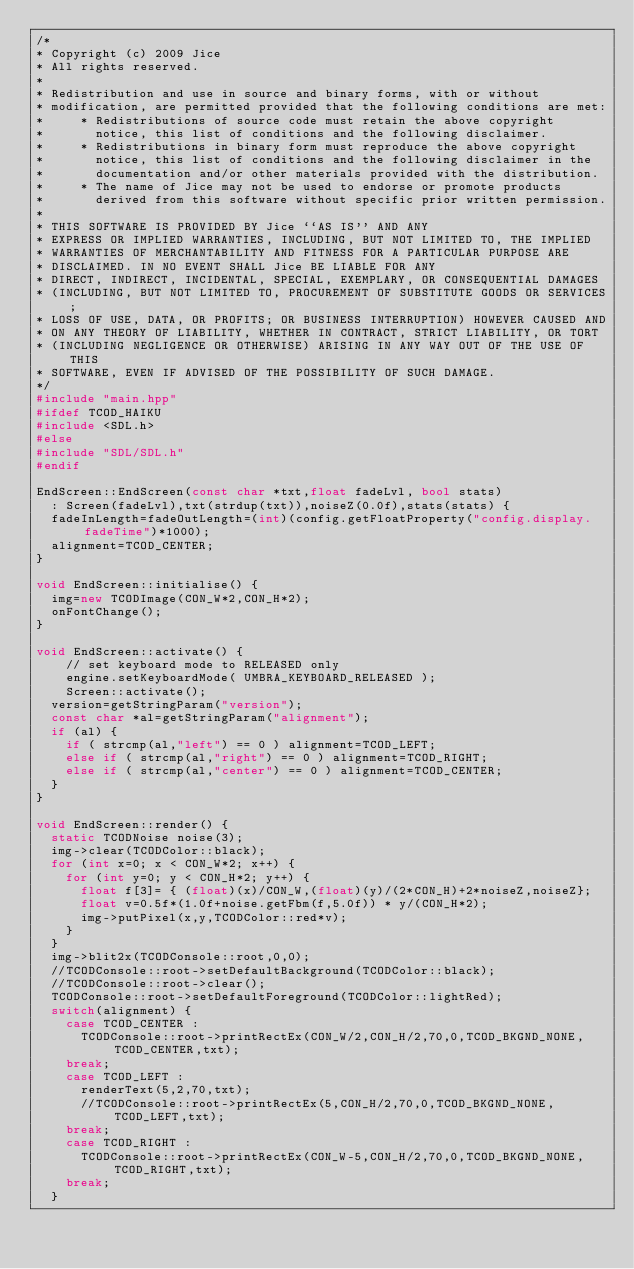Convert code to text. <code><loc_0><loc_0><loc_500><loc_500><_C++_>/*
* Copyright (c) 2009 Jice
* All rights reserved.
*
* Redistribution and use in source and binary forms, with or without
* modification, are permitted provided that the following conditions are met:
*     * Redistributions of source code must retain the above copyright
*       notice, this list of conditions and the following disclaimer.
*     * Redistributions in binary form must reproduce the above copyright
*       notice, this list of conditions and the following disclaimer in the
*       documentation and/or other materials provided with the distribution.
*     * The name of Jice may not be used to endorse or promote products
*       derived from this software without specific prior written permission.
*
* THIS SOFTWARE IS PROVIDED BY Jice ``AS IS'' AND ANY
* EXPRESS OR IMPLIED WARRANTIES, INCLUDING, BUT NOT LIMITED TO, THE IMPLIED
* WARRANTIES OF MERCHANTABILITY AND FITNESS FOR A PARTICULAR PURPOSE ARE
* DISCLAIMED. IN NO EVENT SHALL Jice BE LIABLE FOR ANY
* DIRECT, INDIRECT, INCIDENTAL, SPECIAL, EXEMPLARY, OR CONSEQUENTIAL DAMAGES
* (INCLUDING, BUT NOT LIMITED TO, PROCUREMENT OF SUBSTITUTE GOODS OR SERVICES;
* LOSS OF USE, DATA, OR PROFITS; OR BUSINESS INTERRUPTION) HOWEVER CAUSED AND
* ON ANY THEORY OF LIABILITY, WHETHER IN CONTRACT, STRICT LIABILITY, OR TORT
* (INCLUDING NEGLIGENCE OR OTHERWISE) ARISING IN ANY WAY OUT OF THE USE OF THIS
* SOFTWARE, EVEN IF ADVISED OF THE POSSIBILITY OF SUCH DAMAGE.
*/
#include "main.hpp"
#ifdef TCOD_HAIKU
#include <SDL.h>
#else
#include "SDL/SDL.h"
#endif

EndScreen::EndScreen(const char *txt,float fadeLvl, bool stats)
	: Screen(fadeLvl),txt(strdup(txt)),noiseZ(0.0f),stats(stats) {
	fadeInLength=fadeOutLength=(int)(config.getFloatProperty("config.display.fadeTime")*1000);
	alignment=TCOD_CENTER;
}

void EndScreen::initialise() {
	img=new TCODImage(CON_W*2,CON_H*2);
	onFontChange();
}

void EndScreen::activate() {
    // set keyboard mode to RELEASED only
    engine.setKeyboardMode( UMBRA_KEYBOARD_RELEASED );
    Screen::activate();
	version=getStringParam("version");
	const char *al=getStringParam("alignment");
	if (al) {
		if ( strcmp(al,"left") == 0 ) alignment=TCOD_LEFT;
		else if ( strcmp(al,"right") == 0 ) alignment=TCOD_RIGHT;
		else if ( strcmp(al,"center") == 0 ) alignment=TCOD_CENTER;
	}
}

void EndScreen::render() {
	static TCODNoise noise(3);
	img->clear(TCODColor::black);
	for (int x=0; x < CON_W*2; x++) {
		for (int y=0; y < CON_H*2; y++) {
			float f[3]= { (float)(x)/CON_W,(float)(y)/(2*CON_H)+2*noiseZ,noiseZ};
			float v=0.5f*(1.0f+noise.getFbm(f,5.0f)) * y/(CON_H*2);
			img->putPixel(x,y,TCODColor::red*v);
		}
	}
	img->blit2x(TCODConsole::root,0,0);
	//TCODConsole::root->setDefaultBackground(TCODColor::black);
	//TCODConsole::root->clear();
	TCODConsole::root->setDefaultForeground(TCODColor::lightRed);
	switch(alignment) {
		case TCOD_CENTER :
			TCODConsole::root->printRectEx(CON_W/2,CON_H/2,70,0,TCOD_BKGND_NONE,TCOD_CENTER,txt);
		break;
		case TCOD_LEFT :
			renderText(5,2,70,txt);
			//TCODConsole::root->printRectEx(5,CON_H/2,70,0,TCOD_BKGND_NONE,TCOD_LEFT,txt);
		break;
		case TCOD_RIGHT :
			TCODConsole::root->printRectEx(CON_W-5,CON_H/2,70,0,TCOD_BKGND_NONE,TCOD_RIGHT,txt);
		break;
	}
</code> 